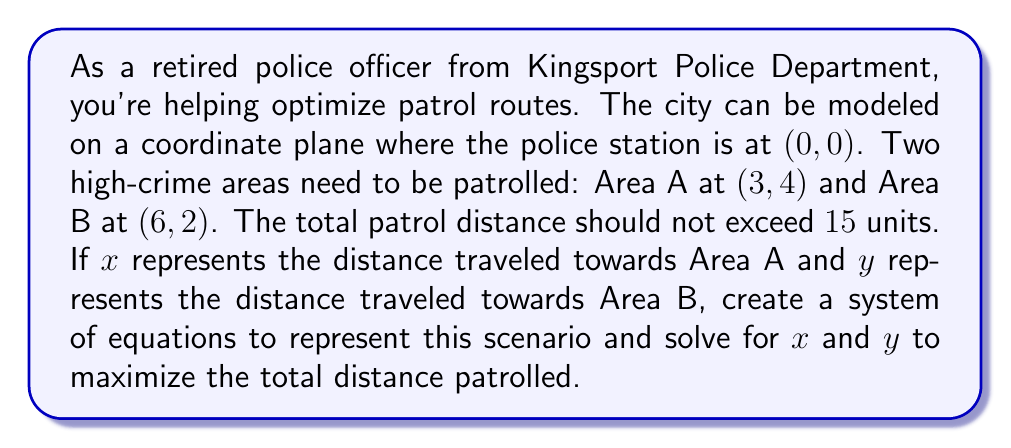Could you help me with this problem? Let's approach this step-by-step:

1) First, we need to set up our equations. We have two constraints:

   a) The total distance traveled should not exceed 15 units:
      $$ x + y = 15 $$

   b) The path must form a right triangle with the two high-crime areas:
      $$ (\frac{x}{3})^2 + (\frac{y}{6})^2 = 1 $$

2) Our goal is to maximize x + y, which is already set to 15. So we just need to find values of x and y that satisfy both equations.

3) Let's substitute the first equation into the second:
   $$ (\frac{x}{3})^2 + (\frac{15-x}{6})^2 = 1 $$

4) Expand this equation:
   $$ \frac{x^2}{9} + \frac{225-30x+x^2}{36} = 1 $$

5) Multiply all terms by 36:
   $$ 4x^2 + 225 - 30x + x^2 = 36 $$

6) Simplify:
   $$ 5x^2 - 30x + 189 = 0 $$

7) This is a quadratic equation. We can solve it using the quadratic formula:
   $$ x = \frac{-b \pm \sqrt{b^2 - 4ac}}{2a} $$
   Where a = 5, b = -30, and c = 189

8) Substituting these values:
   $$ x = \frac{30 \pm \sqrt{900 - 3780}}{10} = \frac{30 \pm \sqrt{-2880}}{10} $$

9) Since we can't have a negative value under the square root, there's only one real solution:
   $$ x = \frac{30}{10} = 3 $$

10) We can find y by substituting x = 3 into our original equation:
    $$ y = 15 - 3 = 12 $$
Answer: The optimal patrol route is to travel 3 units towards Area A and 12 units towards Area B. 